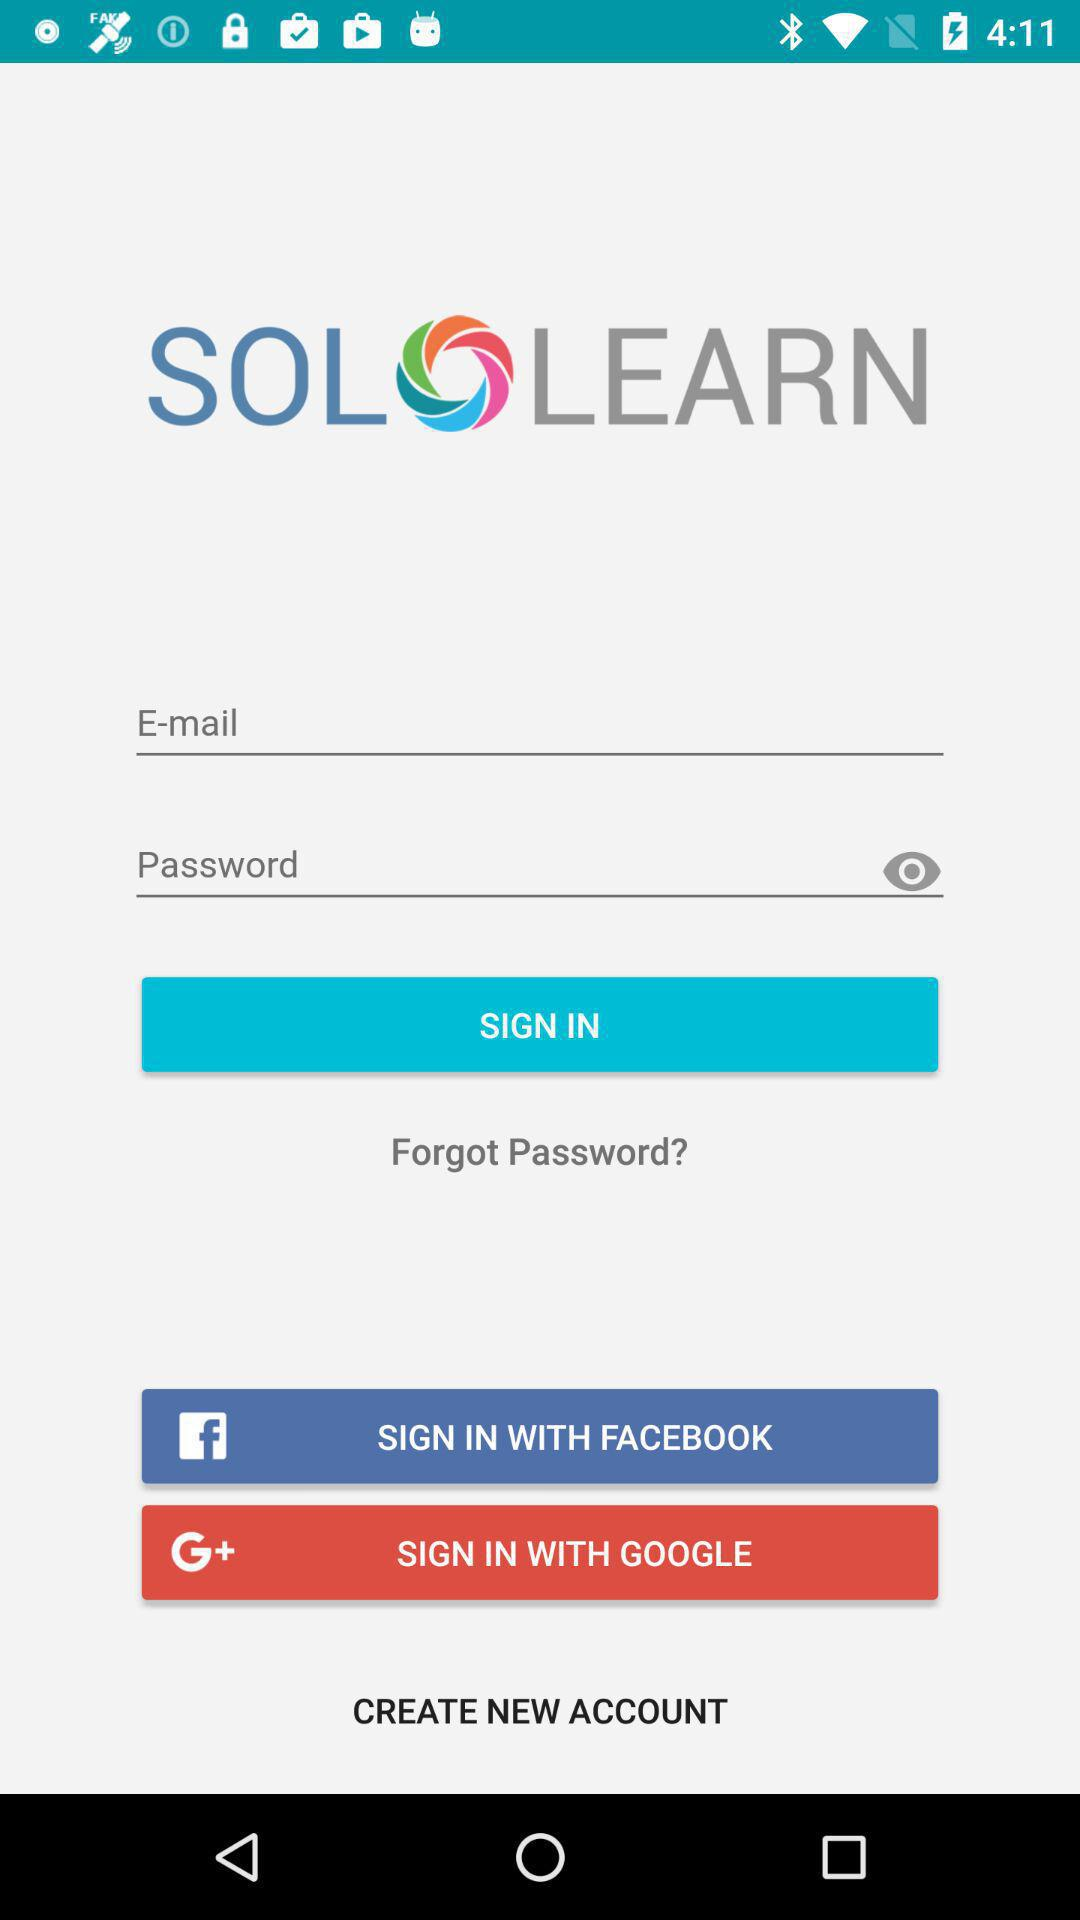What is the application name? The application name is "SOLOLEARN". 